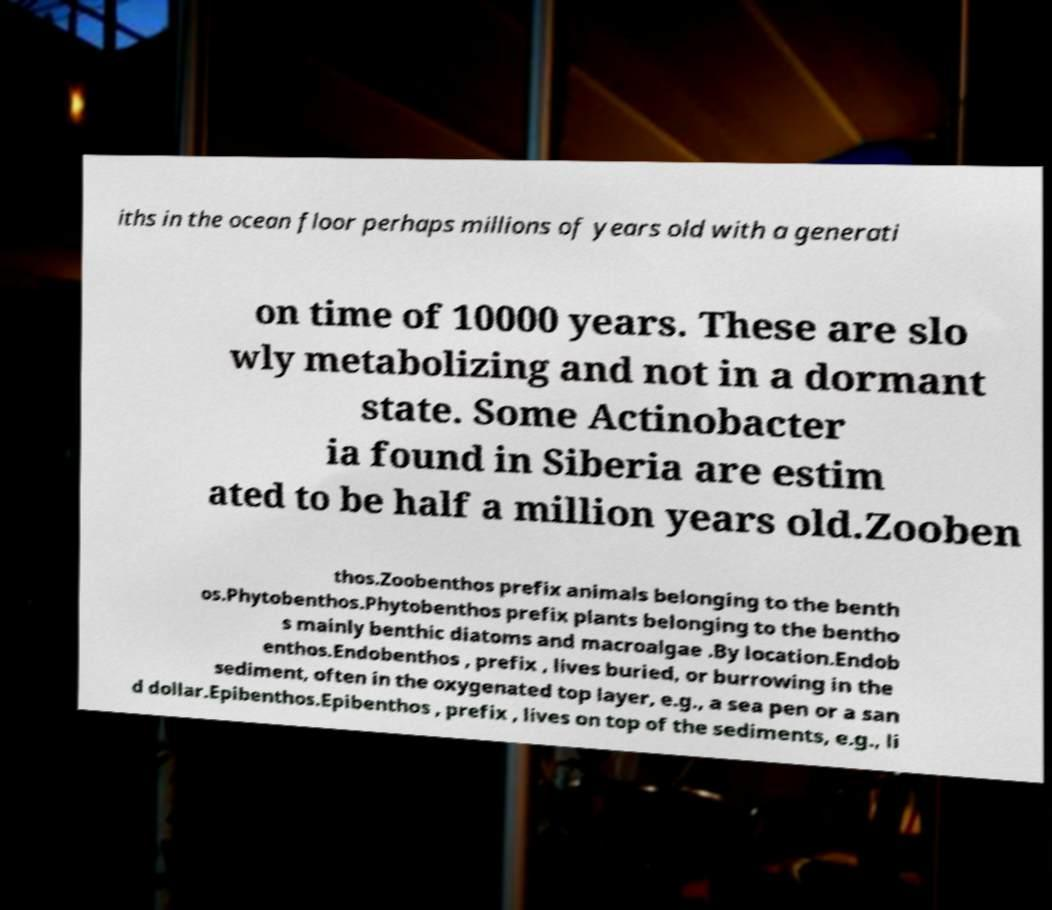Can you accurately transcribe the text from the provided image for me? iths in the ocean floor perhaps millions of years old with a generati on time of 10000 years. These are slo wly metabolizing and not in a dormant state. Some Actinobacter ia found in Siberia are estim ated to be half a million years old.Zooben thos.Zoobenthos prefix animals belonging to the benth os.Phytobenthos.Phytobenthos prefix plants belonging to the bentho s mainly benthic diatoms and macroalgae .By location.Endob enthos.Endobenthos , prefix , lives buried, or burrowing in the sediment, often in the oxygenated top layer, e.g., a sea pen or a san d dollar.Epibenthos.Epibenthos , prefix , lives on top of the sediments, e.g., li 